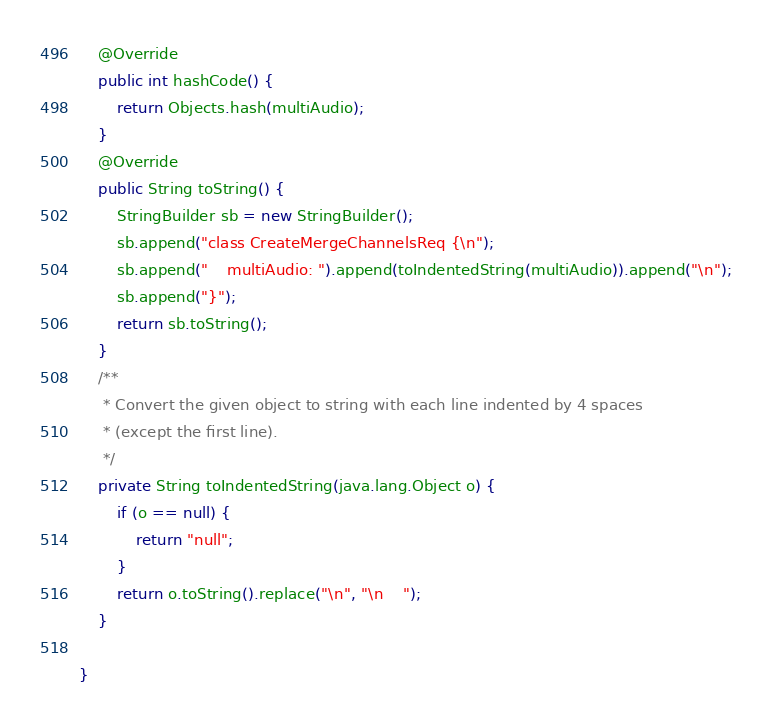Convert code to text. <code><loc_0><loc_0><loc_500><loc_500><_Java_>    @Override
    public int hashCode() {
        return Objects.hash(multiAudio);
    }
    @Override
    public String toString() {
        StringBuilder sb = new StringBuilder();
        sb.append("class CreateMergeChannelsReq {\n");
        sb.append("    multiAudio: ").append(toIndentedString(multiAudio)).append("\n");
        sb.append("}");
        return sb.toString();
    }
    /**
     * Convert the given object to string with each line indented by 4 spaces
     * (except the first line).
     */
    private String toIndentedString(java.lang.Object o) {
        if (o == null) {
            return "null";
        }
        return o.toString().replace("\n", "\n    ");
    }
    
}

</code> 